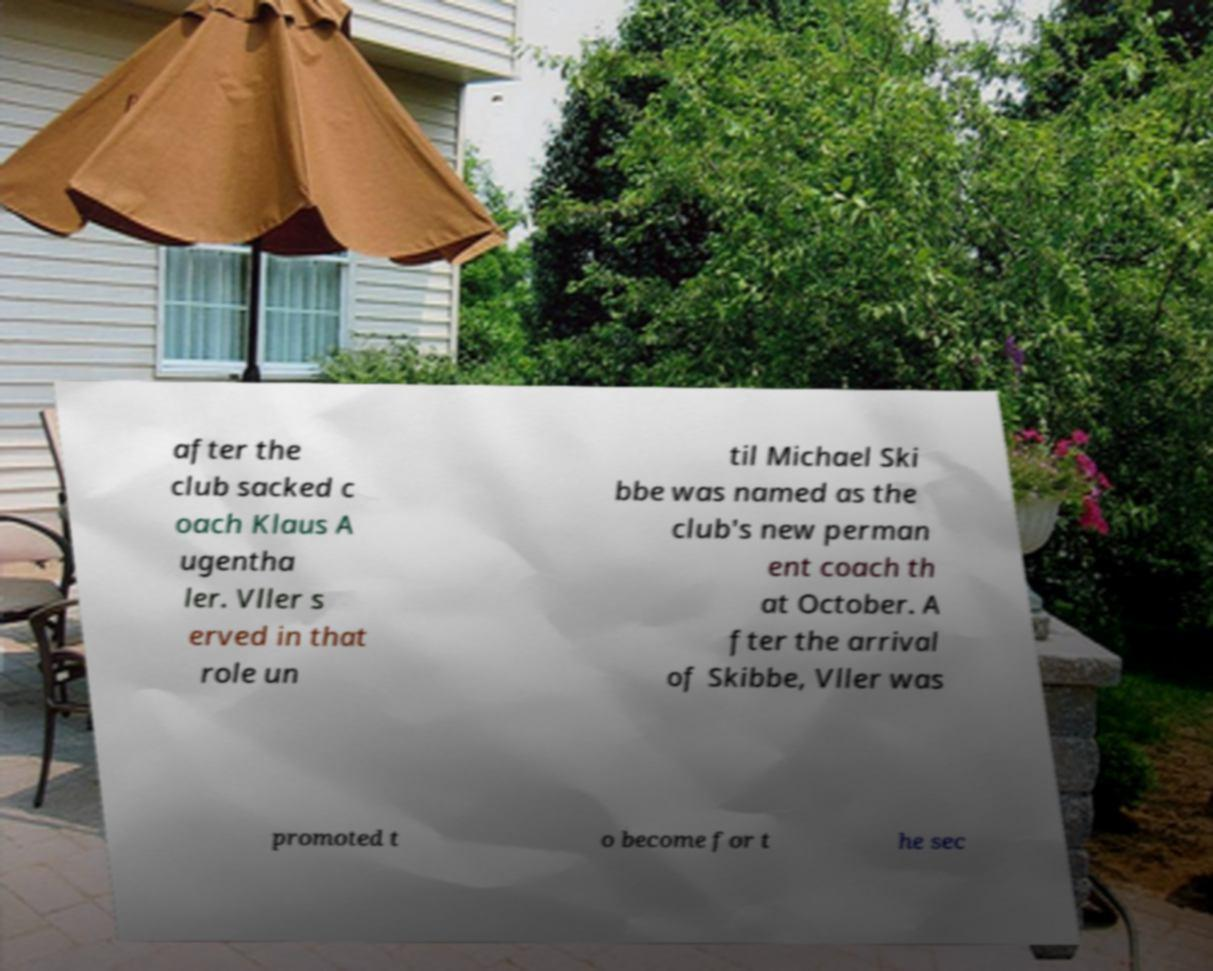Can you read and provide the text displayed in the image?This photo seems to have some interesting text. Can you extract and type it out for me? after the club sacked c oach Klaus A ugentha ler. Vller s erved in that role un til Michael Ski bbe was named as the club's new perman ent coach th at October. A fter the arrival of Skibbe, Vller was promoted t o become for t he sec 